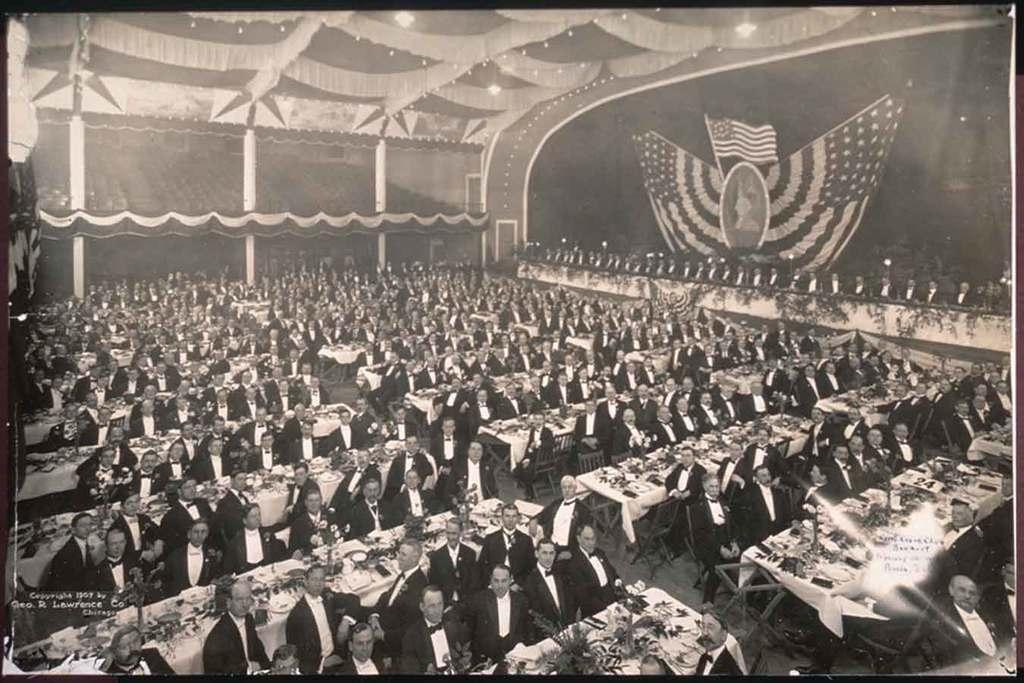In one or two sentences, can you explain what this image depicts? In this image I can see people are sitting on chairs, in-front of them there are tables, above the table there are flowers, vases, plates and objects. In the background of the image I can see a tent, lights, pillars and flags. At the bottom left side and right side of the image there are watermarks. 